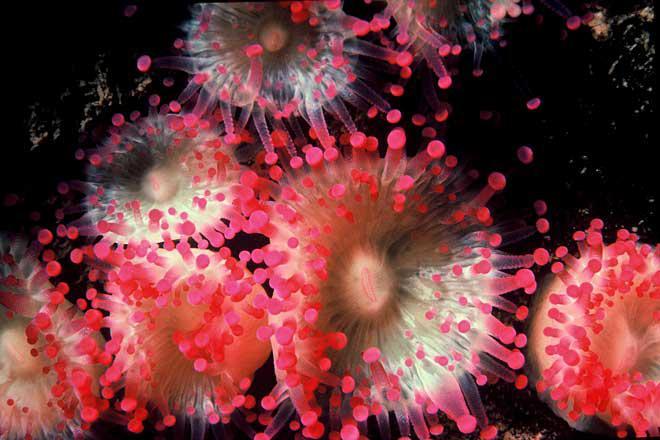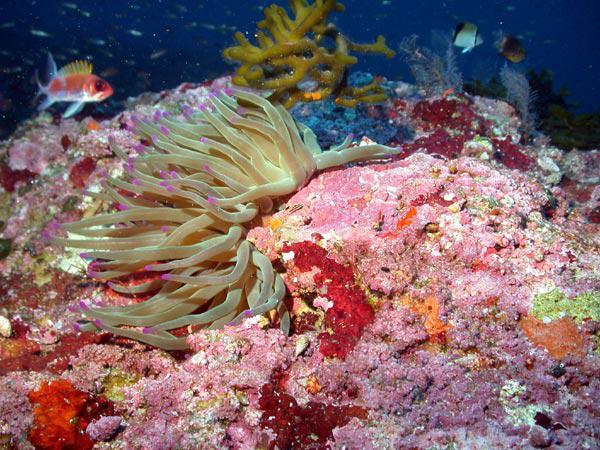The first image is the image on the left, the second image is the image on the right. Considering the images on both sides, is "There are fish hiding inside the anemone." valid? Answer yes or no. No. The first image is the image on the left, the second image is the image on the right. For the images displayed, is the sentence "In there water there are at least 5 corral pieces with two tone colored arms." factually correct? Answer yes or no. Yes. 